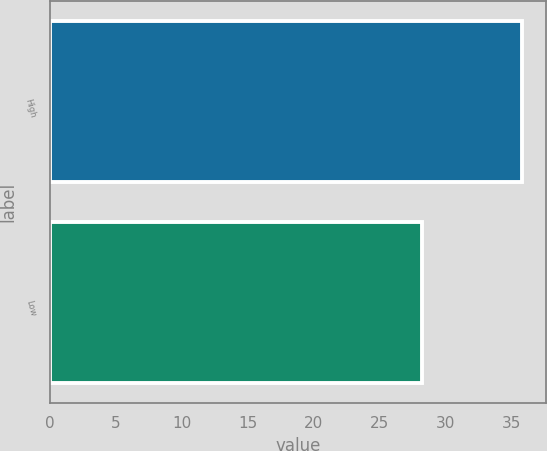Convert chart. <chart><loc_0><loc_0><loc_500><loc_500><bar_chart><fcel>High<fcel>Low<nl><fcel>35.8<fcel>28.18<nl></chart> 